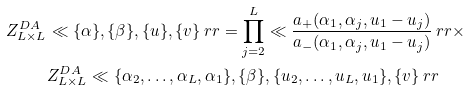<formula> <loc_0><loc_0><loc_500><loc_500>Z ^ { D A } _ { L \times L } & \ll \{ \alpha \} , \{ \beta \} , \{ u \} , \{ v \} \ r r = \prod _ { j = 2 } ^ { L } \ll \frac { a _ { + } ( \alpha _ { 1 } , \alpha _ { j } , u _ { 1 } - u _ { j } ) } { a _ { - } ( \alpha _ { 1 } , \alpha _ { j } , u _ { 1 } - u _ { j } ) } \ r r \times \\ & Z ^ { D A } _ { L \times L } \ll \{ \alpha _ { 2 } , \dots , \alpha _ { L } , \alpha _ { 1 } \} , \{ \beta \} , \{ u _ { 2 } , \dots , u _ { L } , u _ { 1 } \} , \{ v \} \ r r</formula> 